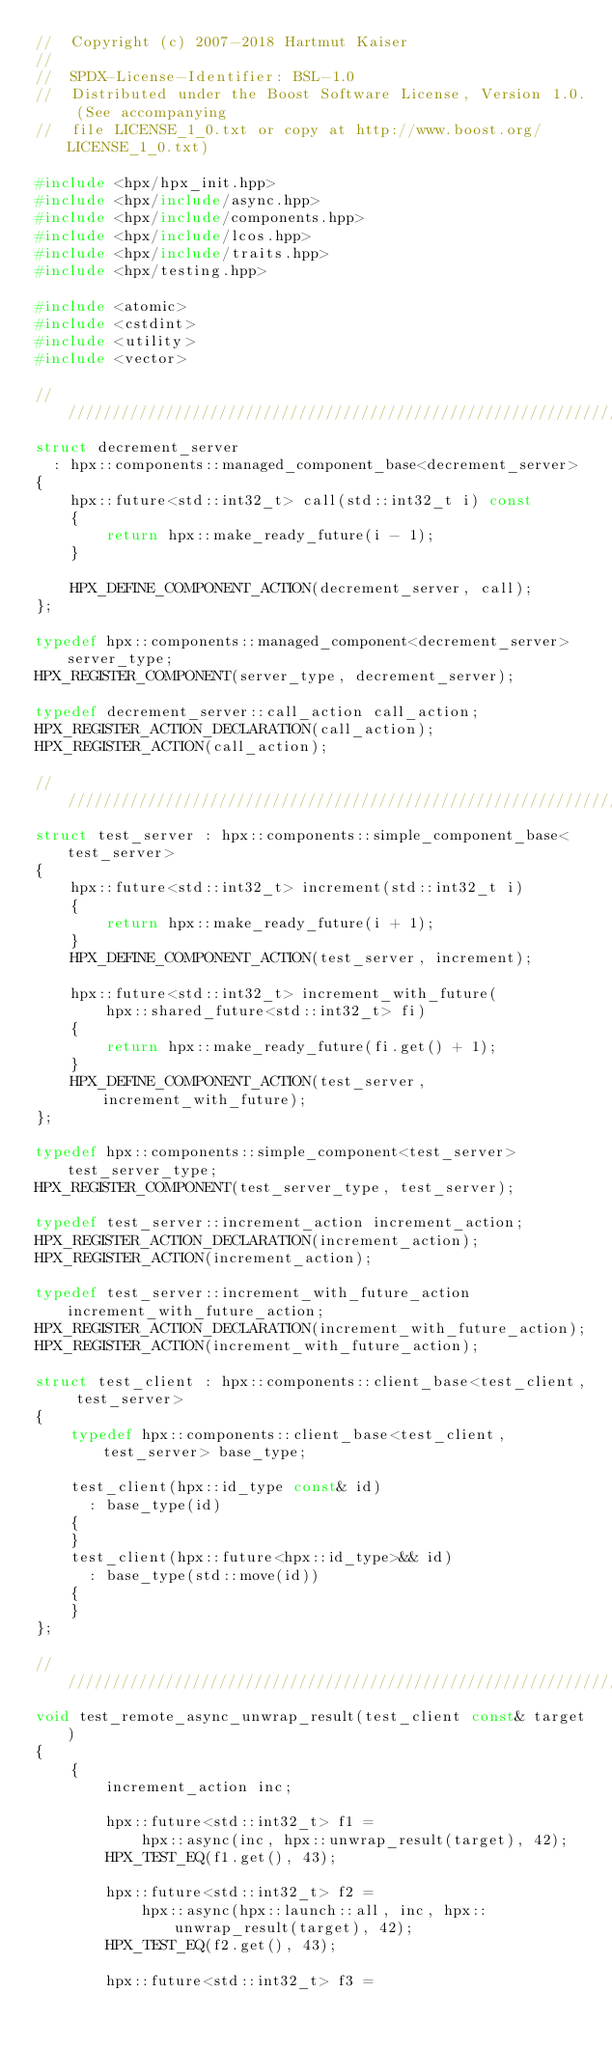<code> <loc_0><loc_0><loc_500><loc_500><_C++_>//  Copyright (c) 2007-2018 Hartmut Kaiser
//
//  SPDX-License-Identifier: BSL-1.0
//  Distributed under the Boost Software License, Version 1.0. (See accompanying
//  file LICENSE_1_0.txt or copy at http://www.boost.org/LICENSE_1_0.txt)

#include <hpx/hpx_init.hpp>
#include <hpx/include/async.hpp>
#include <hpx/include/components.hpp>
#include <hpx/include/lcos.hpp>
#include <hpx/include/traits.hpp>
#include <hpx/testing.hpp>

#include <atomic>
#include <cstdint>
#include <utility>
#include <vector>

///////////////////////////////////////////////////////////////////////////////
struct decrement_server
  : hpx::components::managed_component_base<decrement_server>
{
    hpx::future<std::int32_t> call(std::int32_t i) const
    {
        return hpx::make_ready_future(i - 1);
    }

    HPX_DEFINE_COMPONENT_ACTION(decrement_server, call);
};

typedef hpx::components::managed_component<decrement_server> server_type;
HPX_REGISTER_COMPONENT(server_type, decrement_server);

typedef decrement_server::call_action call_action;
HPX_REGISTER_ACTION_DECLARATION(call_action);
HPX_REGISTER_ACTION(call_action);

///////////////////////////////////////////////////////////////////////////////
struct test_server : hpx::components::simple_component_base<test_server>
{
    hpx::future<std::int32_t> increment(std::int32_t i)
    {
        return hpx::make_ready_future(i + 1);
    }
    HPX_DEFINE_COMPONENT_ACTION(test_server, increment);

    hpx::future<std::int32_t> increment_with_future(
        hpx::shared_future<std::int32_t> fi)
    {
        return hpx::make_ready_future(fi.get() + 1);
    }
    HPX_DEFINE_COMPONENT_ACTION(test_server, increment_with_future);
};

typedef hpx::components::simple_component<test_server> test_server_type;
HPX_REGISTER_COMPONENT(test_server_type, test_server);

typedef test_server::increment_action increment_action;
HPX_REGISTER_ACTION_DECLARATION(increment_action);
HPX_REGISTER_ACTION(increment_action);

typedef test_server::increment_with_future_action increment_with_future_action;
HPX_REGISTER_ACTION_DECLARATION(increment_with_future_action);
HPX_REGISTER_ACTION(increment_with_future_action);

struct test_client : hpx::components::client_base<test_client, test_server>
{
    typedef hpx::components::client_base<test_client, test_server> base_type;

    test_client(hpx::id_type const& id)
      : base_type(id)
    {
    }
    test_client(hpx::future<hpx::id_type>&& id)
      : base_type(std::move(id))
    {
    }
};

///////////////////////////////////////////////////////////////////////////////
void test_remote_async_unwrap_result(test_client const& target)
{
    {
        increment_action inc;

        hpx::future<std::int32_t> f1 =
            hpx::async(inc, hpx::unwrap_result(target), 42);
        HPX_TEST_EQ(f1.get(), 43);

        hpx::future<std::int32_t> f2 =
            hpx::async(hpx::launch::all, inc, hpx::unwrap_result(target), 42);
        HPX_TEST_EQ(f2.get(), 43);

        hpx::future<std::int32_t> f3 =</code> 